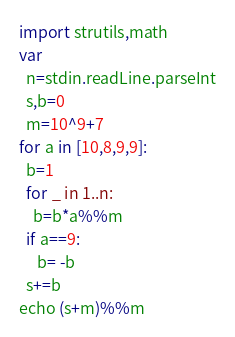Convert code to text. <code><loc_0><loc_0><loc_500><loc_500><_Nim_>import strutils,math
var
  n=stdin.readLine.parseInt
  s,b=0
  m=10^9+7
for a in [10,8,9,9]:
  b=1
  for _ in 1..n:
    b=b*a%%m
  if a==9:
     b= -b
  s+=b
echo (s+m)%%m</code> 